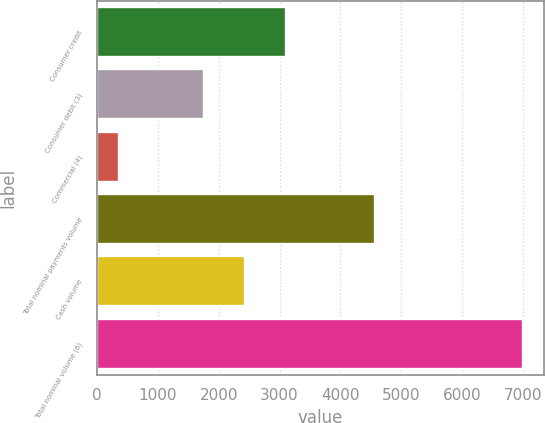Convert chart to OTSL. <chart><loc_0><loc_0><loc_500><loc_500><bar_chart><fcel>Consumer credit<fcel>Consumer debit (3)<fcel>Commercial (4)<fcel>Total nominal payments volume<fcel>Cash volume<fcel>Total nominal volume (6)<nl><fcel>3098.5<fcel>1757<fcel>363<fcel>4562<fcel>2435<fcel>6998<nl></chart> 